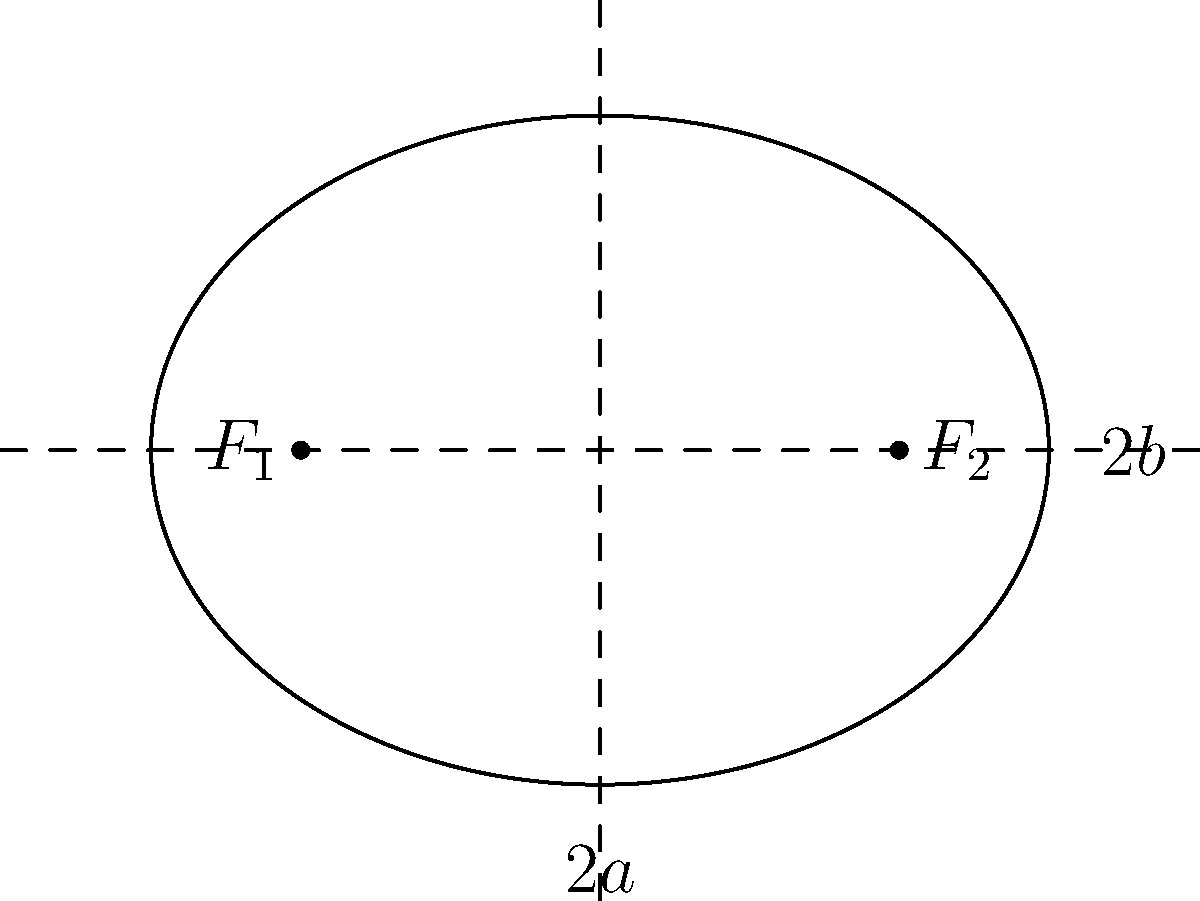In creative writing, the structure of a story can often be compared to the shape of an ellipse. Consider the ellipse shown above, where the foci represent key plot points and the distance between them symbolizes the narrative arc. If the major axis (2a) of this ellipse is 6 units and the distance between the foci is 4 units, calculate the eccentricity of the ellipse. How might this eccentricity relate to the pacing and tension in a story? To solve this problem and relate it to storytelling, let's follow these steps:

1) First, recall the formula for eccentricity (e) of an ellipse:
   $$e = \frac{c}{a}$$
   where c is the distance from the center to a focus, and a is the length of the semi-major axis.

2) We're given that the major axis (2a) is 6 units, so:
   $$a = 3$$

3) The distance between the foci is 4 units, so:
   $$2c = 4$$
   $$c = 2$$

4) Now we can calculate the eccentricity:
   $$e = \frac{c}{a} = \frac{2}{3} \approx 0.667$$

5) To relate this to storytelling:
   - Eccentricity ranges from 0 (a circle) to nearly 1 (a very elongated ellipse).
   - An eccentricity of 0.667 is moderately high, indicating a somewhat elongated ellipse.
   - In storytelling terms, this could represent a narrative with clear, separated key events (the foci) and a significant journey or development between them.
   - The moderate elongation might suggest a story with steady pacing and building tension, rather than a circular plot (low eccentricity) or a very stretched out, potentially slow-moving narrative (high eccentricity).
   - The balance between the major and minor axes (represented by the eccentricity) could symbolize the balance between the main plot and subplots in the story.
Answer: Eccentricity = 2/3 ≈ 0.667; represents moderate narrative tension and steady plot development. 